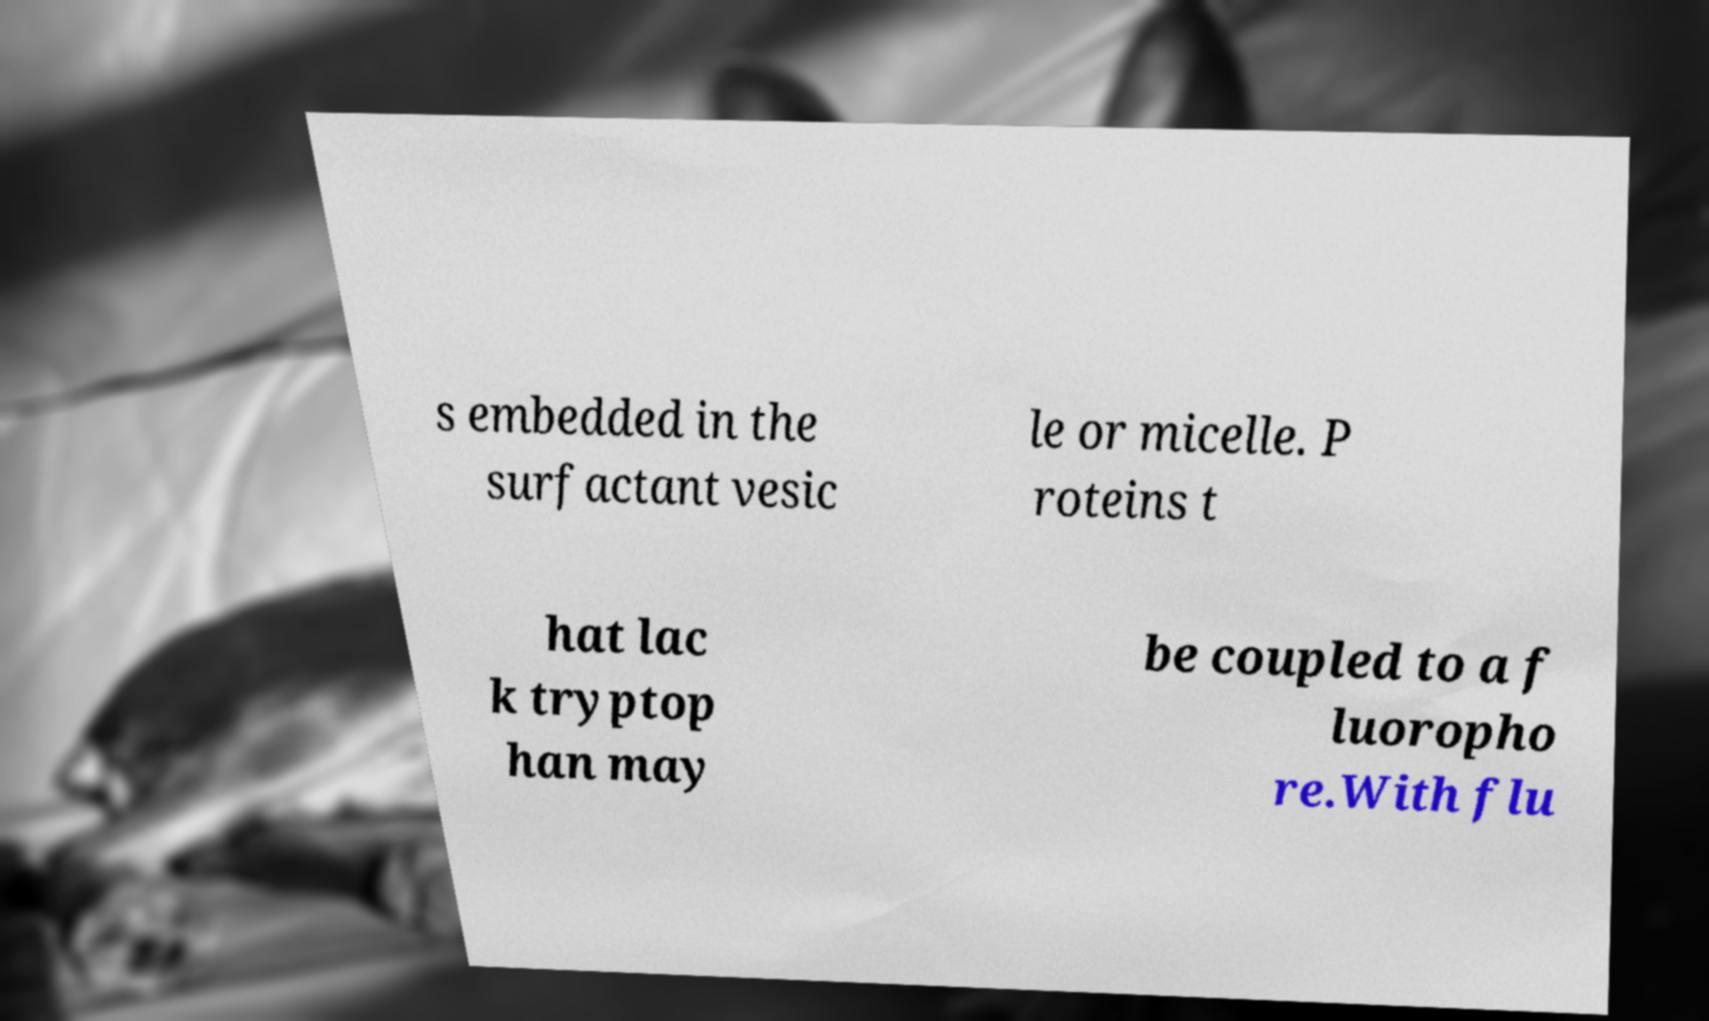For documentation purposes, I need the text within this image transcribed. Could you provide that? s embedded in the surfactant vesic le or micelle. P roteins t hat lac k tryptop han may be coupled to a f luoropho re.With flu 